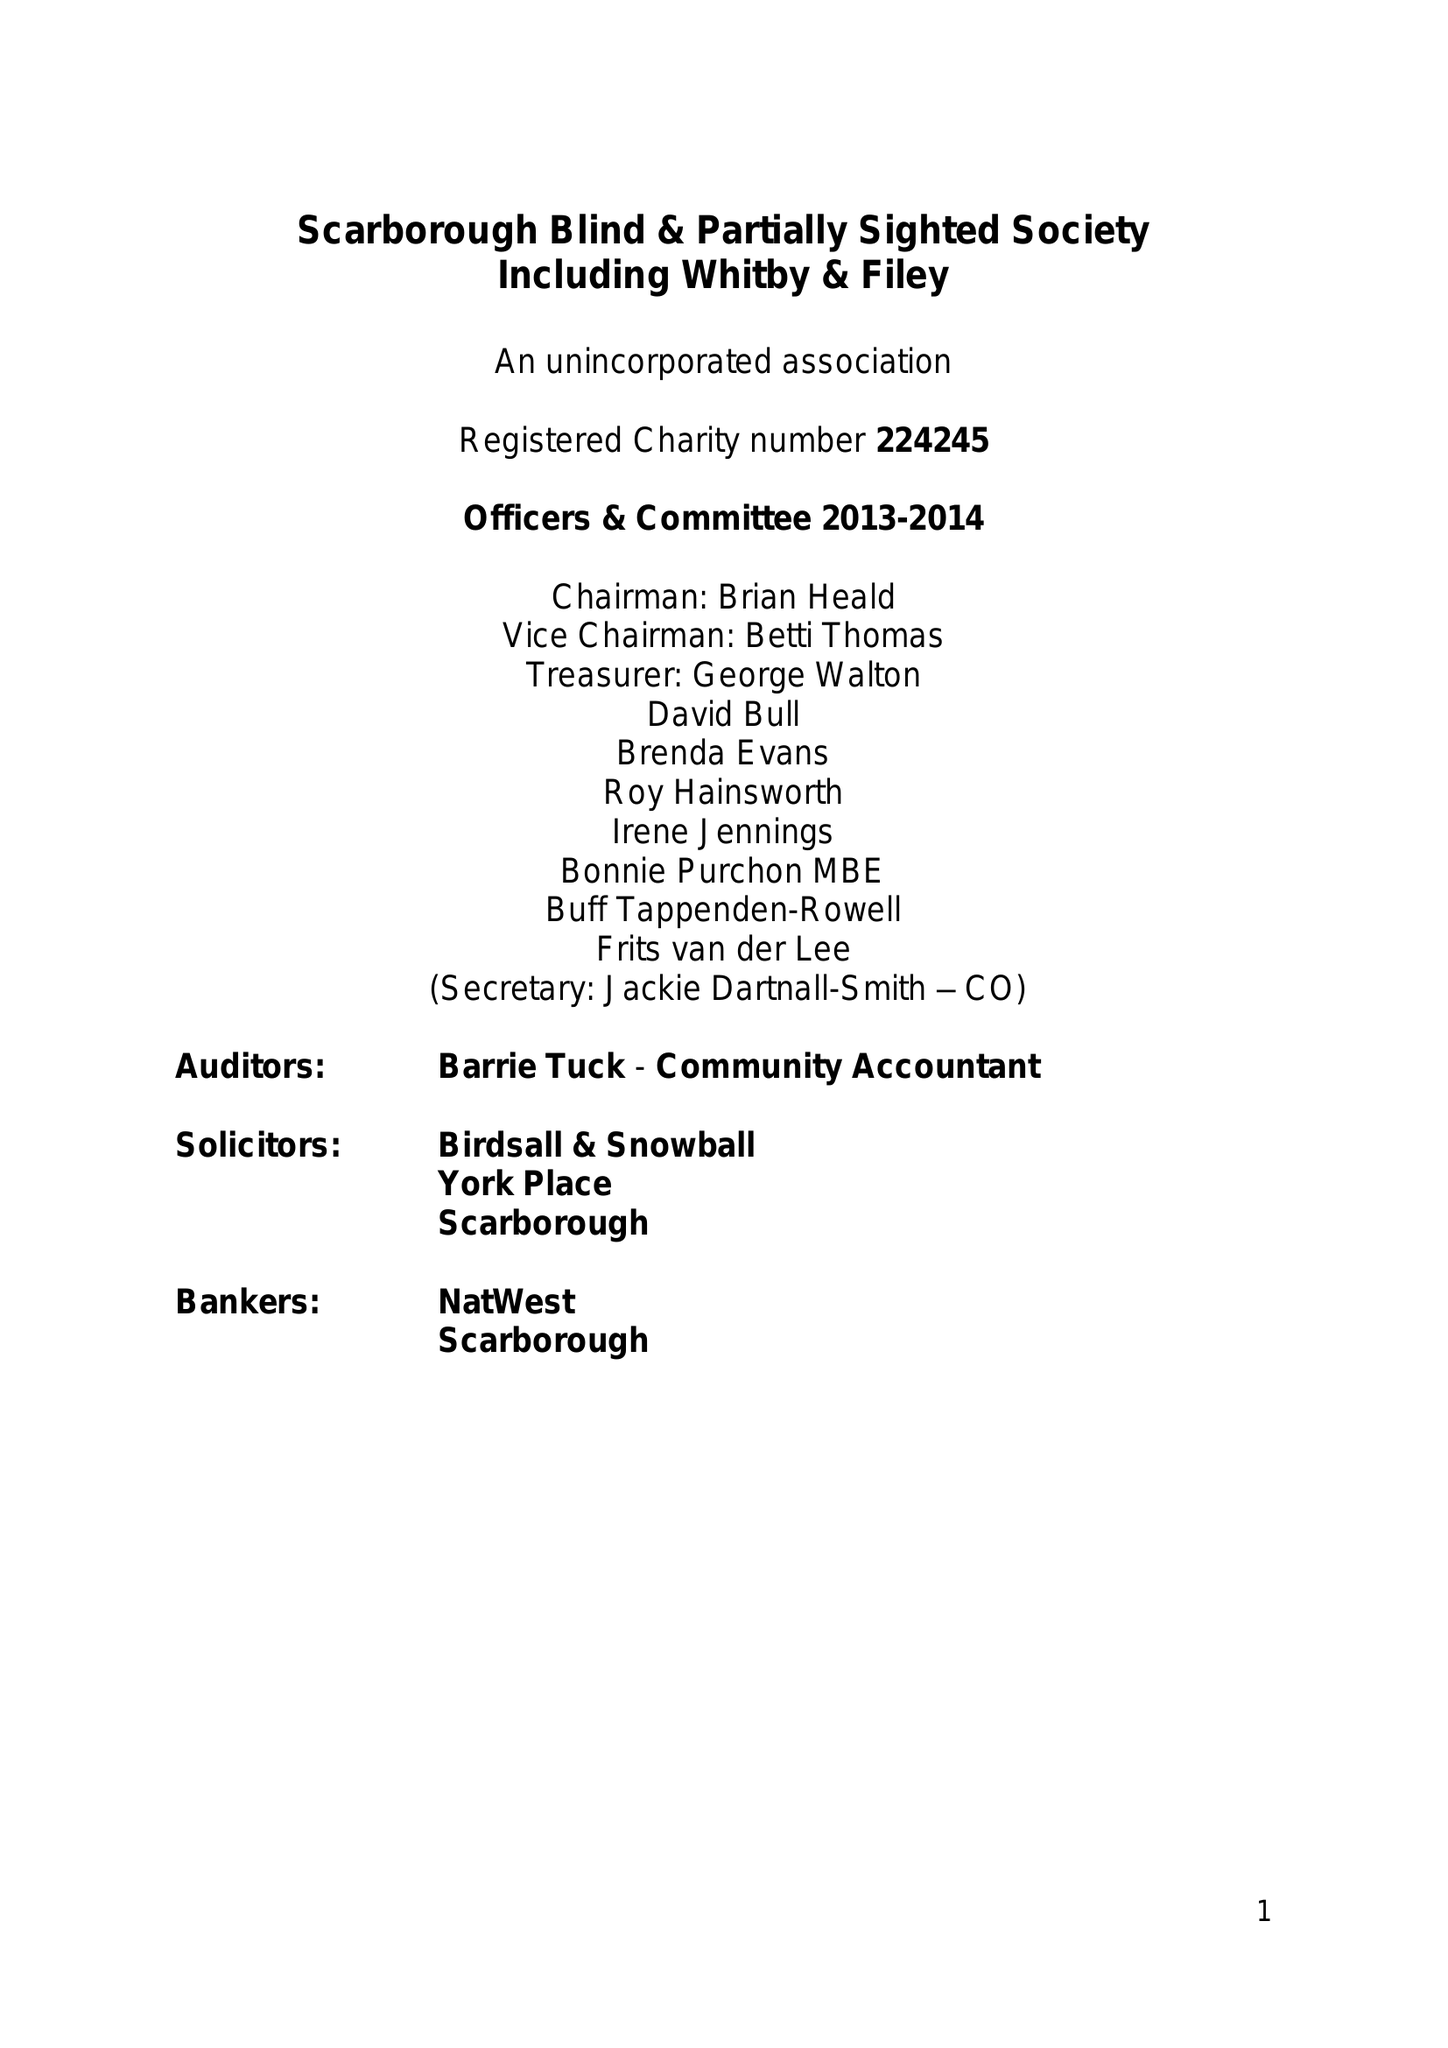What is the value for the spending_annually_in_british_pounds?
Answer the question using a single word or phrase. 112942.00 